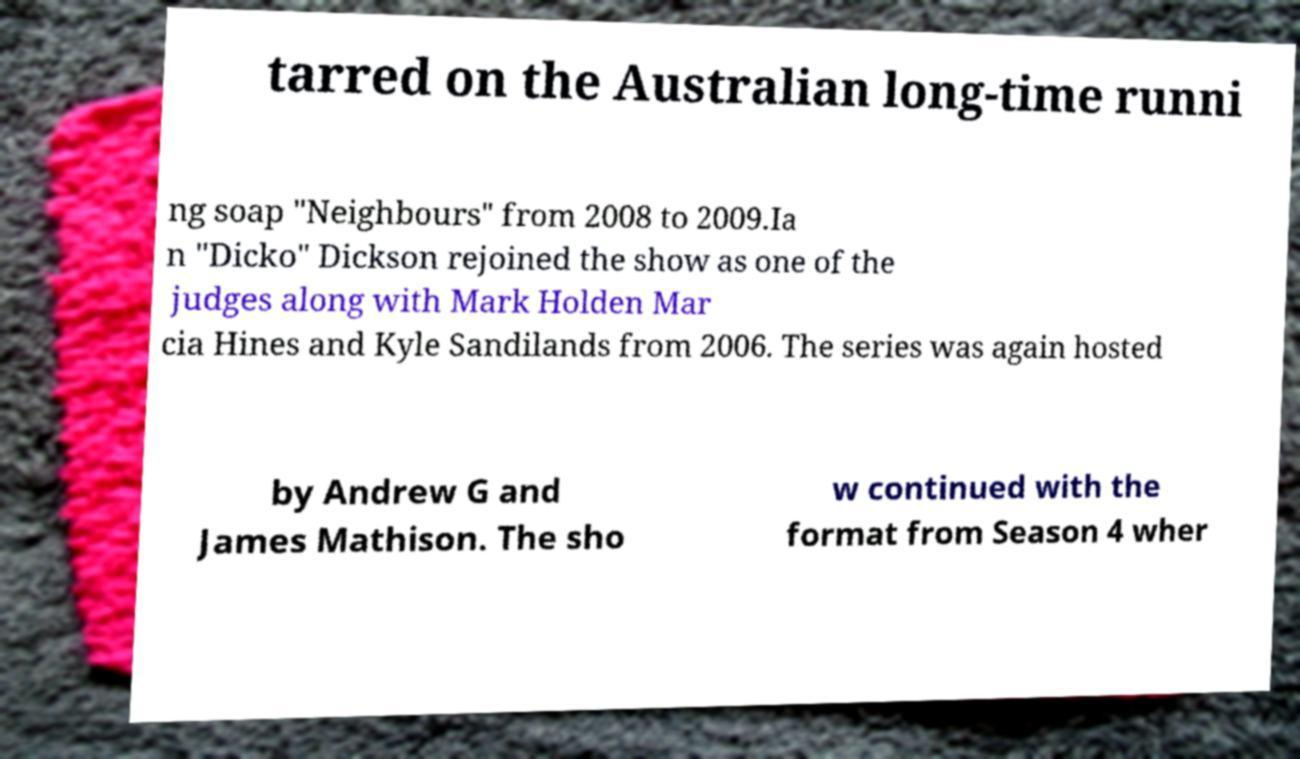Can you accurately transcribe the text from the provided image for me? tarred on the Australian long-time runni ng soap "Neighbours" from 2008 to 2009.Ia n "Dicko" Dickson rejoined the show as one of the judges along with Mark Holden Mar cia Hines and Kyle Sandilands from 2006. The series was again hosted by Andrew G and James Mathison. The sho w continued with the format from Season 4 wher 